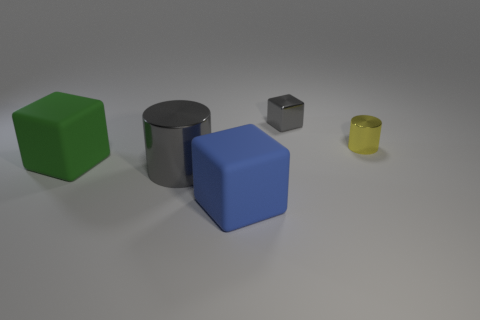Add 1 large green matte objects. How many objects exist? 6 Subtract all blocks. How many objects are left? 2 Subtract all large matte things. Subtract all cubes. How many objects are left? 0 Add 5 metal objects. How many metal objects are left? 8 Add 1 small green rubber spheres. How many small green rubber spheres exist? 1 Subtract 1 green cubes. How many objects are left? 4 